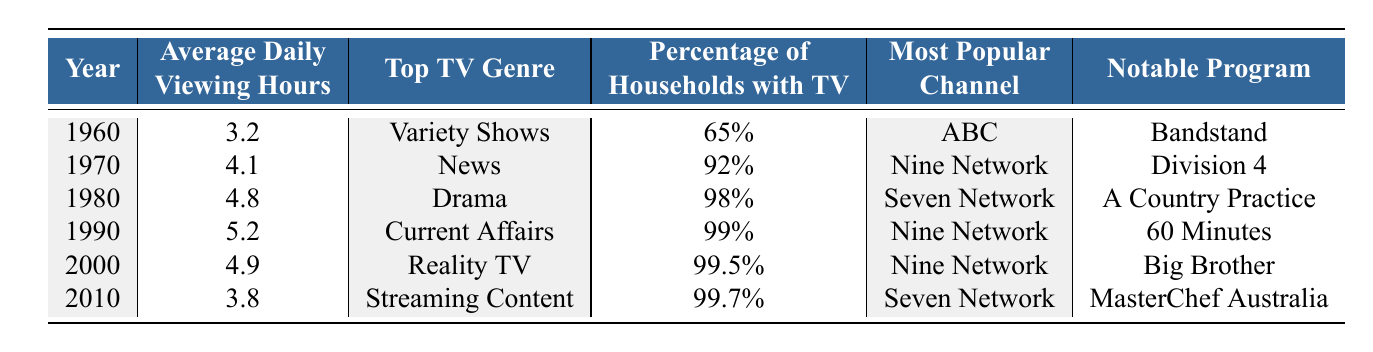What was the top TV genre in 1990? The table shows that in 1990, the top TV genre listed is 'Current Affairs.'
Answer: Current Affairs How many households had a TV in 1980? According to the table, in 1980, 98% of households had a TV.
Answer: 98% What is the average daily viewing hours from 1960 to 2010? To find the average, we sum the viewing hours: (3.2 + 4.1 + 4.8 + 5.2 + 4.9 + 3.8) = 26.0, and we divide by the number of years (6): 26.0 / 6 = 4.33.
Answer: 4.33 What notable program aired on the Nine Network during the 1990s? The table indicates that '60 Minutes' was the notable program on the Nine Network in 1990, which is part of the 1990s.
Answer: 60 Minutes Did the percentage of households with a TV ever reach 100% from 1960 to 2010? The table records the highest percentage at 99.7% in 2010, which is below 100%, so the answer is no.
Answer: No Which channel was most popular in 2000? According to the table, the Nine Network was the most popular channel in 2000.
Answer: Nine Network What was the trend in average daily viewing hours from 1990 to 2010? The average viewing hours in 1990 was 5.2 and decreased to 3.8 by 2010, indicating a downward trend over the 20 years.
Answer: Downward trend What was the top TV genre in 2000 compared to 2010? The top genre in 2000 was 'Reality TV,' while in 2010 it shifted to 'Streaming Content.' This shows a change in audience preference from traditional reality shows to streaming formats.
Answer: Change from Reality TV to Streaming Content How much did the average daily viewing hours decrease from 1980 to 2010? The viewing hours in 1980 were 4.8 and decreased to 3.8 in 2010. The decrease is calculated as 4.8 - 3.8 = 1.0 hour.
Answer: 1.0 hour Which notable program was associated with 'Variety Shows' in 1960? The table indicates that 'Bandstand' was the notable program associated with the 'Variety Shows' genre in 1960.
Answer: Bandstand 